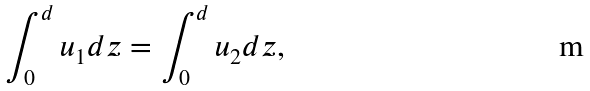Convert formula to latex. <formula><loc_0><loc_0><loc_500><loc_500>\int _ { 0 } ^ { d } u _ { 1 } d z = \int _ { 0 } ^ { d } u _ { 2 } d z ,</formula> 